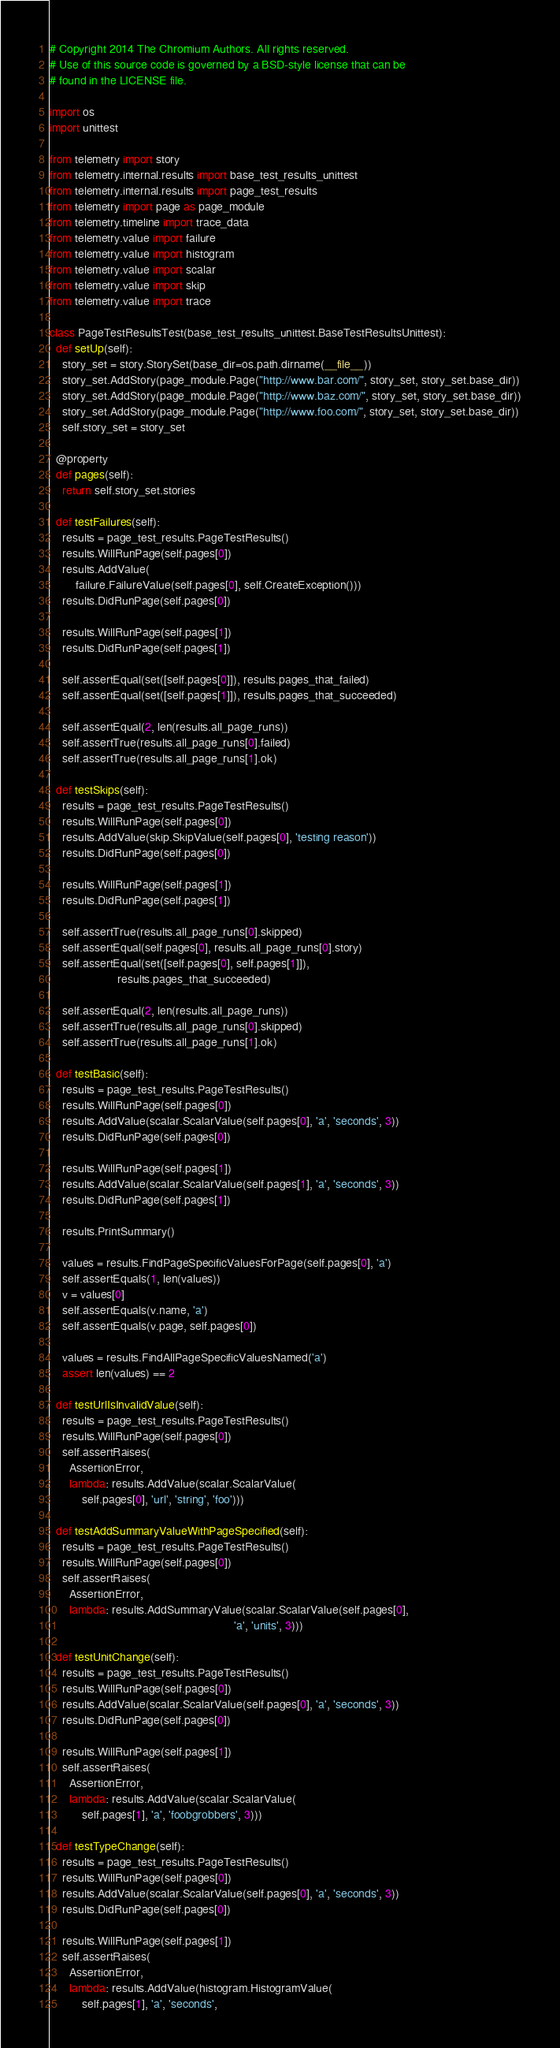<code> <loc_0><loc_0><loc_500><loc_500><_Python_># Copyright 2014 The Chromium Authors. All rights reserved.
# Use of this source code is governed by a BSD-style license that can be
# found in the LICENSE file.

import os
import unittest

from telemetry import story
from telemetry.internal.results import base_test_results_unittest
from telemetry.internal.results import page_test_results
from telemetry import page as page_module
from telemetry.timeline import trace_data
from telemetry.value import failure
from telemetry.value import histogram
from telemetry.value import scalar
from telemetry.value import skip
from telemetry.value import trace

class PageTestResultsTest(base_test_results_unittest.BaseTestResultsUnittest):
  def setUp(self):
    story_set = story.StorySet(base_dir=os.path.dirname(__file__))
    story_set.AddStory(page_module.Page("http://www.bar.com/", story_set, story_set.base_dir))
    story_set.AddStory(page_module.Page("http://www.baz.com/", story_set, story_set.base_dir))
    story_set.AddStory(page_module.Page("http://www.foo.com/", story_set, story_set.base_dir))
    self.story_set = story_set

  @property
  def pages(self):
    return self.story_set.stories

  def testFailures(self):
    results = page_test_results.PageTestResults()
    results.WillRunPage(self.pages[0])
    results.AddValue(
        failure.FailureValue(self.pages[0], self.CreateException()))
    results.DidRunPage(self.pages[0])

    results.WillRunPage(self.pages[1])
    results.DidRunPage(self.pages[1])

    self.assertEqual(set([self.pages[0]]), results.pages_that_failed)
    self.assertEqual(set([self.pages[1]]), results.pages_that_succeeded)

    self.assertEqual(2, len(results.all_page_runs))
    self.assertTrue(results.all_page_runs[0].failed)
    self.assertTrue(results.all_page_runs[1].ok)

  def testSkips(self):
    results = page_test_results.PageTestResults()
    results.WillRunPage(self.pages[0])
    results.AddValue(skip.SkipValue(self.pages[0], 'testing reason'))
    results.DidRunPage(self.pages[0])

    results.WillRunPage(self.pages[1])
    results.DidRunPage(self.pages[1])

    self.assertTrue(results.all_page_runs[0].skipped)
    self.assertEqual(self.pages[0], results.all_page_runs[0].story)
    self.assertEqual(set([self.pages[0], self.pages[1]]),
                     results.pages_that_succeeded)

    self.assertEqual(2, len(results.all_page_runs))
    self.assertTrue(results.all_page_runs[0].skipped)
    self.assertTrue(results.all_page_runs[1].ok)

  def testBasic(self):
    results = page_test_results.PageTestResults()
    results.WillRunPage(self.pages[0])
    results.AddValue(scalar.ScalarValue(self.pages[0], 'a', 'seconds', 3))
    results.DidRunPage(self.pages[0])

    results.WillRunPage(self.pages[1])
    results.AddValue(scalar.ScalarValue(self.pages[1], 'a', 'seconds', 3))
    results.DidRunPage(self.pages[1])

    results.PrintSummary()

    values = results.FindPageSpecificValuesForPage(self.pages[0], 'a')
    self.assertEquals(1, len(values))
    v = values[0]
    self.assertEquals(v.name, 'a')
    self.assertEquals(v.page, self.pages[0])

    values = results.FindAllPageSpecificValuesNamed('a')
    assert len(values) == 2

  def testUrlIsInvalidValue(self):
    results = page_test_results.PageTestResults()
    results.WillRunPage(self.pages[0])
    self.assertRaises(
      AssertionError,
      lambda: results.AddValue(scalar.ScalarValue(
          self.pages[0], 'url', 'string', 'foo')))

  def testAddSummaryValueWithPageSpecified(self):
    results = page_test_results.PageTestResults()
    results.WillRunPage(self.pages[0])
    self.assertRaises(
      AssertionError,
      lambda: results.AddSummaryValue(scalar.ScalarValue(self.pages[0],
                                                         'a', 'units', 3)))

  def testUnitChange(self):
    results = page_test_results.PageTestResults()
    results.WillRunPage(self.pages[0])
    results.AddValue(scalar.ScalarValue(self.pages[0], 'a', 'seconds', 3))
    results.DidRunPage(self.pages[0])

    results.WillRunPage(self.pages[1])
    self.assertRaises(
      AssertionError,
      lambda: results.AddValue(scalar.ScalarValue(
          self.pages[1], 'a', 'foobgrobbers', 3)))

  def testTypeChange(self):
    results = page_test_results.PageTestResults()
    results.WillRunPage(self.pages[0])
    results.AddValue(scalar.ScalarValue(self.pages[0], 'a', 'seconds', 3))
    results.DidRunPage(self.pages[0])

    results.WillRunPage(self.pages[1])
    self.assertRaises(
      AssertionError,
      lambda: results.AddValue(histogram.HistogramValue(
          self.pages[1], 'a', 'seconds',</code> 